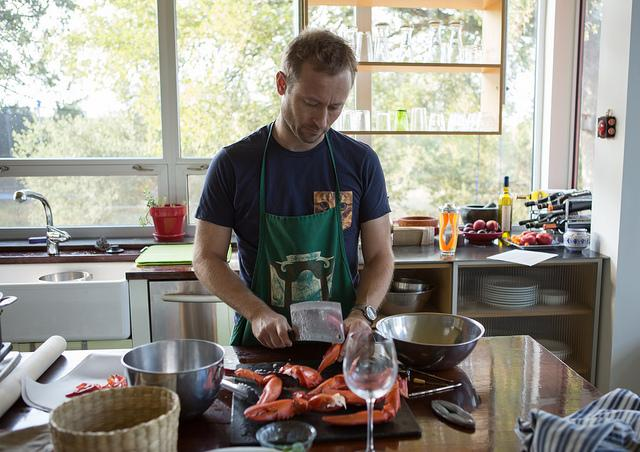What is the man in the apron cooking? Please explain your reasoning. lobster. There are lobsters on the table in front of him. 